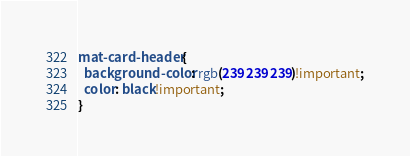<code> <loc_0><loc_0><loc_500><loc_500><_CSS_>mat-card-header {
  background-color: rgb(239 239 239)!important;
  color: black!important;
}</code> 